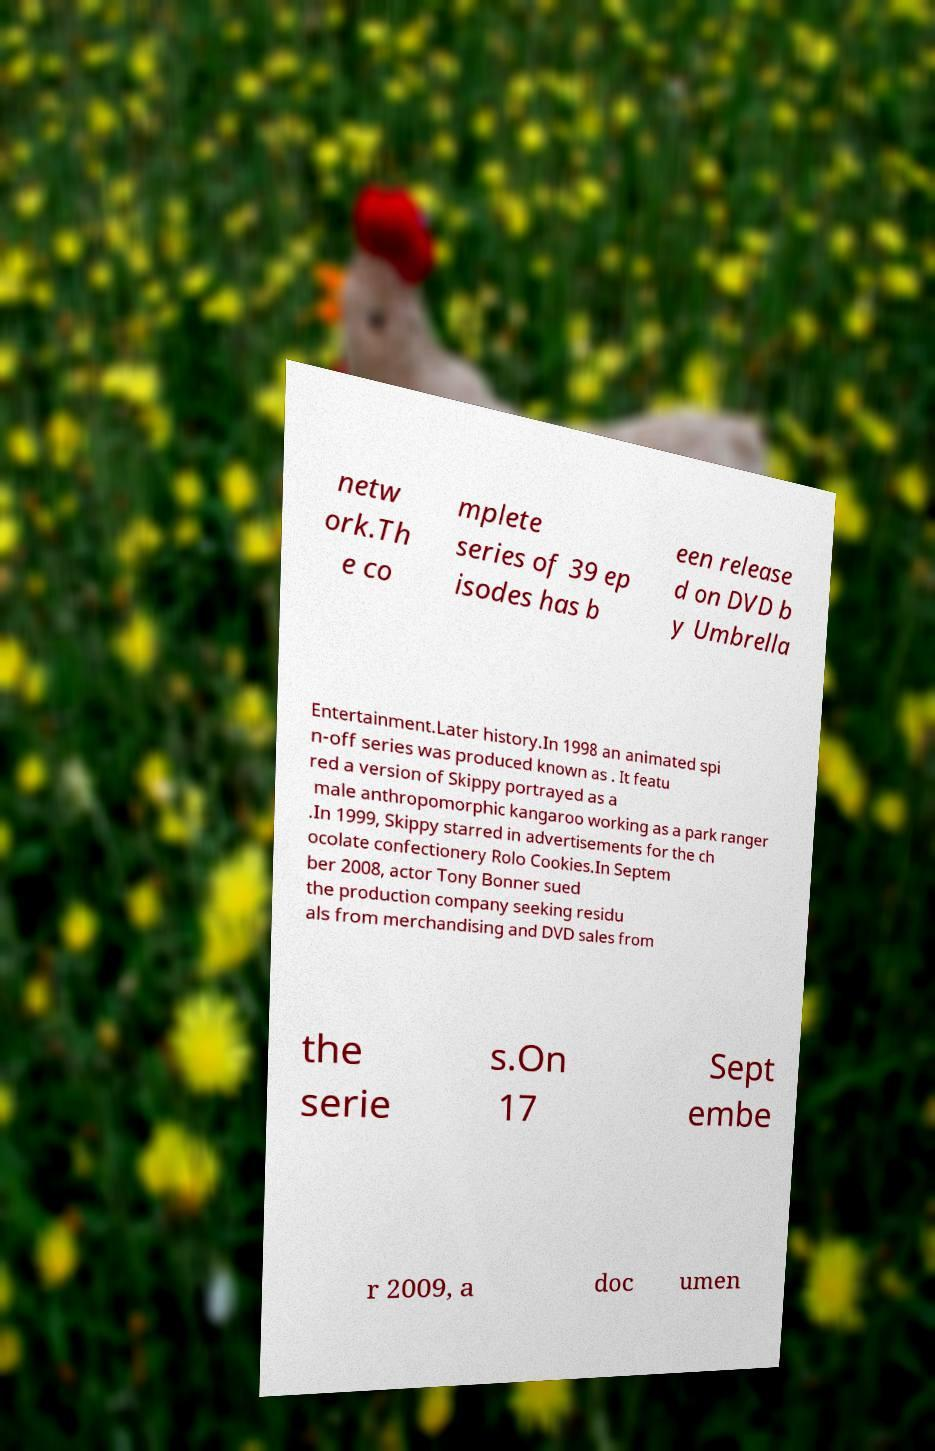Please read and relay the text visible in this image. What does it say? netw ork.Th e co mplete series of 39 ep isodes has b een release d on DVD b y Umbrella Entertainment.Later history.In 1998 an animated spi n-off series was produced known as . It featu red a version of Skippy portrayed as a male anthropomorphic kangaroo working as a park ranger .In 1999, Skippy starred in advertisements for the ch ocolate confectionery Rolo Cookies.In Septem ber 2008, actor Tony Bonner sued the production company seeking residu als from merchandising and DVD sales from the serie s.On 17 Sept embe r 2009, a doc umen 